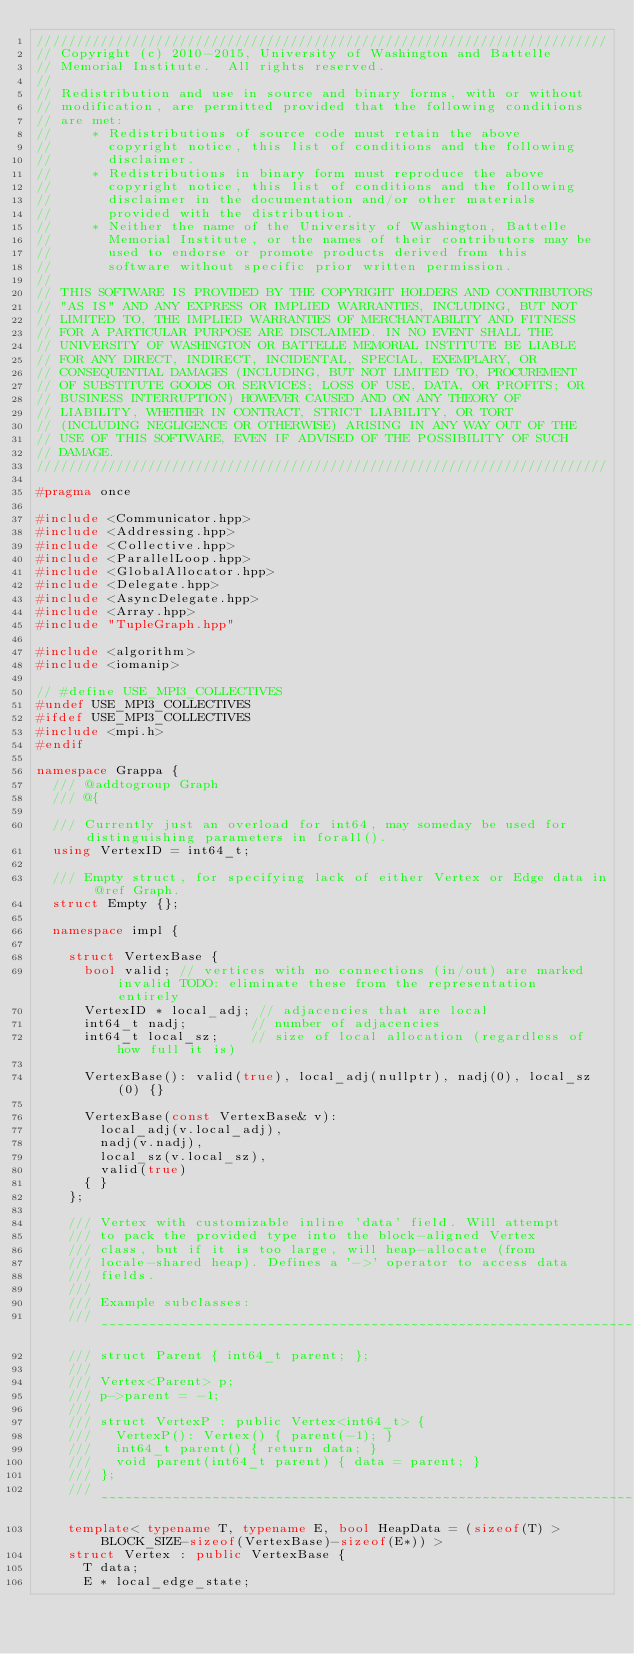<code> <loc_0><loc_0><loc_500><loc_500><_C++_>////////////////////////////////////////////////////////////////////////
// Copyright (c) 2010-2015, University of Washington and Battelle
// Memorial Institute.  All rights reserved.
//
// Redistribution and use in source and binary forms, with or without
// modification, are permitted provided that the following conditions
// are met:
//     * Redistributions of source code must retain the above
//       copyright notice, this list of conditions and the following
//       disclaimer.
//     * Redistributions in binary form must reproduce the above
//       copyright notice, this list of conditions and the following
//       disclaimer in the documentation and/or other materials
//       provided with the distribution.
//     * Neither the name of the University of Washington, Battelle
//       Memorial Institute, or the names of their contributors may be
//       used to endorse or promote products derived from this
//       software without specific prior written permission.
//
// THIS SOFTWARE IS PROVIDED BY THE COPYRIGHT HOLDERS AND CONTRIBUTORS
// "AS IS" AND ANY EXPRESS OR IMPLIED WARRANTIES, INCLUDING, BUT NOT
// LIMITED TO, THE IMPLIED WARRANTIES OF MERCHANTABILITY AND FITNESS
// FOR A PARTICULAR PURPOSE ARE DISCLAIMED. IN NO EVENT SHALL THE
// UNIVERSITY OF WASHINGTON OR BATTELLE MEMORIAL INSTITUTE BE LIABLE
// FOR ANY DIRECT, INDIRECT, INCIDENTAL, SPECIAL, EXEMPLARY, OR
// CONSEQUENTIAL DAMAGES (INCLUDING, BUT NOT LIMITED TO, PROCUREMENT
// OF SUBSTITUTE GOODS OR SERVICES; LOSS OF USE, DATA, OR PROFITS; OR
// BUSINESS INTERRUPTION) HOWEVER CAUSED AND ON ANY THEORY OF
// LIABILITY, WHETHER IN CONTRACT, STRICT LIABILITY, OR TORT
// (INCLUDING NEGLIGENCE OR OTHERWISE) ARISING IN ANY WAY OUT OF THE
// USE OF THIS SOFTWARE, EVEN IF ADVISED OF THE POSSIBILITY OF SUCH
// DAMAGE.
////////////////////////////////////////////////////////////////////////

#pragma once

#include <Communicator.hpp>
#include <Addressing.hpp>
#include <Collective.hpp>
#include <ParallelLoop.hpp>
#include <GlobalAllocator.hpp>
#include <Delegate.hpp>
#include <AsyncDelegate.hpp>
#include <Array.hpp>
#include "TupleGraph.hpp"

#include <algorithm>
#include <iomanip>

// #define USE_MPI3_COLLECTIVES
#undef USE_MPI3_COLLECTIVES
#ifdef USE_MPI3_COLLECTIVES
#include <mpi.h>
#endif

namespace Grappa {
  /// @addtogroup Graph
  /// @{
  
  /// Currently just an overload for int64, may someday be used for distinguishing parameters in forall().
  using VertexID = int64_t;
  
  /// Empty struct, for specifying lack of either Vertex or Edge data in @ref Graph.
  struct Empty {};
  
  namespace impl {
    
    struct VertexBase {
      bool valid; // vertices with no connections (in/out) are marked invalid TODO: eliminate these from the representation entirely
      VertexID * local_adj; // adjacencies that are local
      int64_t nadj;        // number of adjacencies
      int64_t local_sz;    // size of local allocation (regardless of how full it is)
      
      VertexBase(): valid(true), local_adj(nullptr), nadj(0), local_sz(0) {}
      
      VertexBase(const VertexBase& v):
        local_adj(v.local_adj),
        nadj(v.nadj),
        local_sz(v.local_sz),
        valid(true)
      { }
    };
    
    /// Vertex with customizable inline 'data' field. Will attempt 
    /// to pack the provided type into the block-aligned Vertex 
    /// class, but if it is too large, will heap-allocate (from 
    /// locale-shared heap). Defines a '->' operator to access data 
    /// fields.
    ///
    /// Example subclasses:
    /// ~~~~~~~~~~~~~~~~~~~~~~~~~~~~~~~~~~~~~~~~~~~~~~~~~~~~~~~~~~~~~~~~~~~~
    /// struct Parent { int64_t parent; };
    /// 
    /// Vertex<Parent> p;
    /// p->parent = -1;
    ///
    /// struct VertexP : public Vertex<int64_t> {
    ///   VertexP(): Vertex() { parent(-1); }
    ///   int64_t parent() { return data; }
    ///   void parent(int64_t parent) { data = parent; }
    /// };
    /// ~~~~~~~~~~~~~~~~~~~~~~~~~~~~~~~~~~~~~~~~~~~~~~~~~~~~~~~~~~~~~~~~~~~~
    template< typename T, typename E, bool HeapData = (sizeof(T) > BLOCK_SIZE-sizeof(VertexBase)-sizeof(E*)) >
    struct Vertex : public VertexBase {
      T data;
      E * local_edge_state;
    </code> 